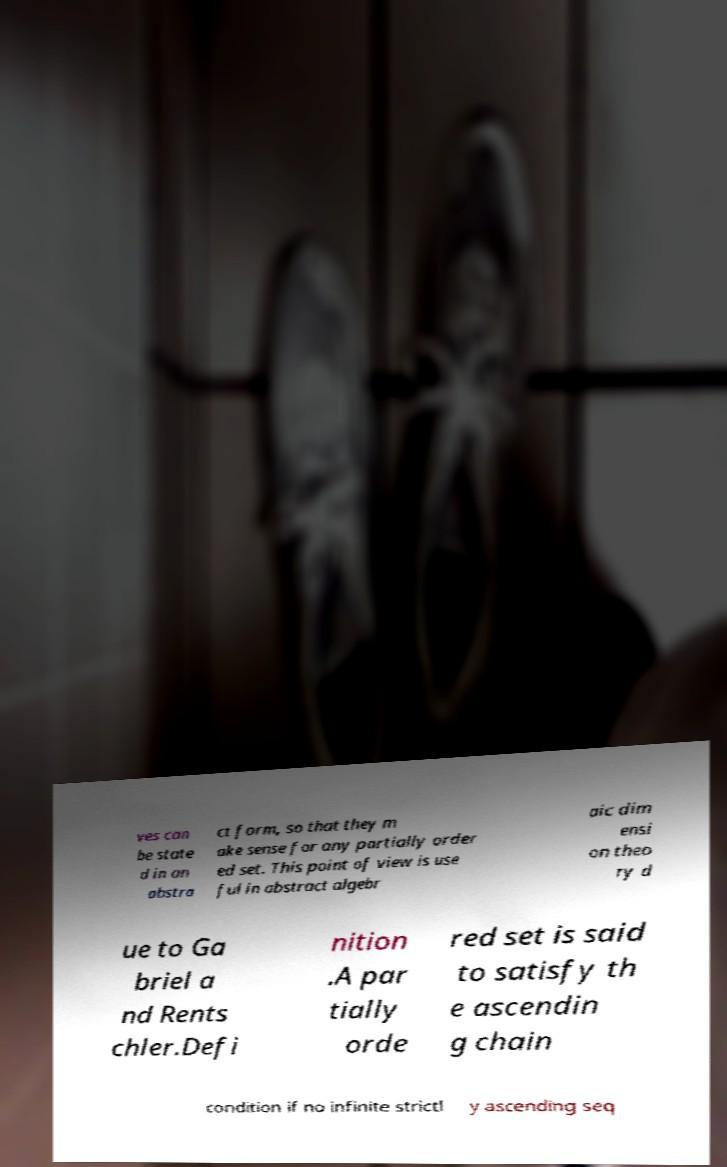Can you accurately transcribe the text from the provided image for me? ves can be state d in an abstra ct form, so that they m ake sense for any partially order ed set. This point of view is use ful in abstract algebr aic dim ensi on theo ry d ue to Ga briel a nd Rents chler.Defi nition .A par tially orde red set is said to satisfy th e ascendin g chain condition if no infinite strictl y ascending seq 